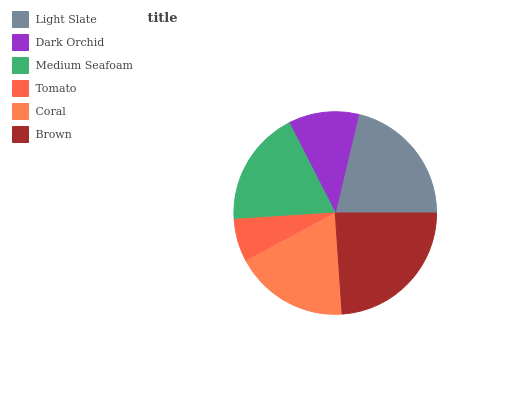Is Tomato the minimum?
Answer yes or no. Yes. Is Brown the maximum?
Answer yes or no. Yes. Is Dark Orchid the minimum?
Answer yes or no. No. Is Dark Orchid the maximum?
Answer yes or no. No. Is Light Slate greater than Dark Orchid?
Answer yes or no. Yes. Is Dark Orchid less than Light Slate?
Answer yes or no. Yes. Is Dark Orchid greater than Light Slate?
Answer yes or no. No. Is Light Slate less than Dark Orchid?
Answer yes or no. No. Is Medium Seafoam the high median?
Answer yes or no. Yes. Is Coral the low median?
Answer yes or no. Yes. Is Dark Orchid the high median?
Answer yes or no. No. Is Medium Seafoam the low median?
Answer yes or no. No. 